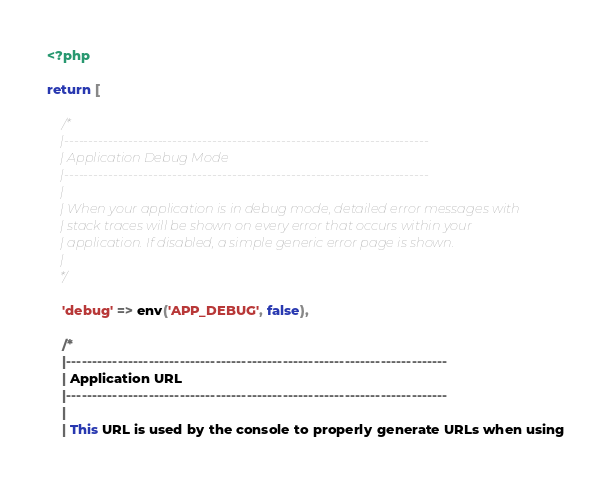Convert code to text. <code><loc_0><loc_0><loc_500><loc_500><_PHP_><?php

return [

	/*
	|--------------------------------------------------------------------------
	| Application Debug Mode
	|--------------------------------------------------------------------------
	|
	| When your application is in debug mode, detailed error messages with
	| stack traces will be shown on every error that occurs within your
	| application. If disabled, a simple generic error page is shown.
	|
	*/

	'debug' => env('APP_DEBUG', false),

	/*
	|--------------------------------------------------------------------------
	| Application URL
	|--------------------------------------------------------------------------
	|
	| This URL is used by the console to properly generate URLs when using</code> 